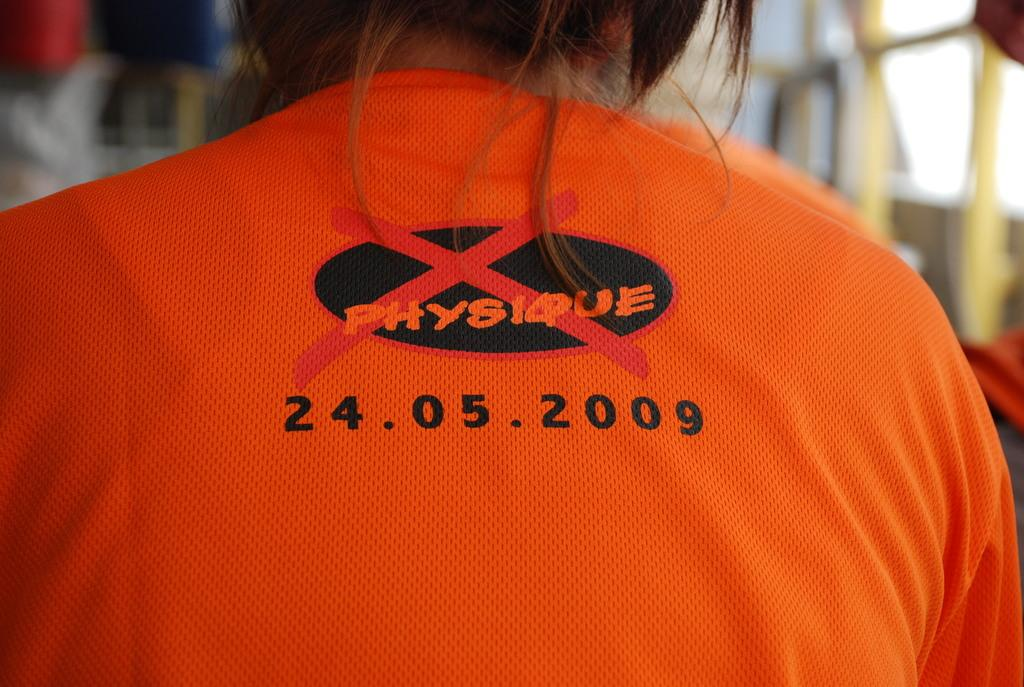<image>
Offer a succinct explanation of the picture presented. On the orange top the word physique is crossed out. 